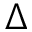<formula> <loc_0><loc_0><loc_500><loc_500>\Delta</formula> 